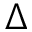<formula> <loc_0><loc_0><loc_500><loc_500>\Delta</formula> 